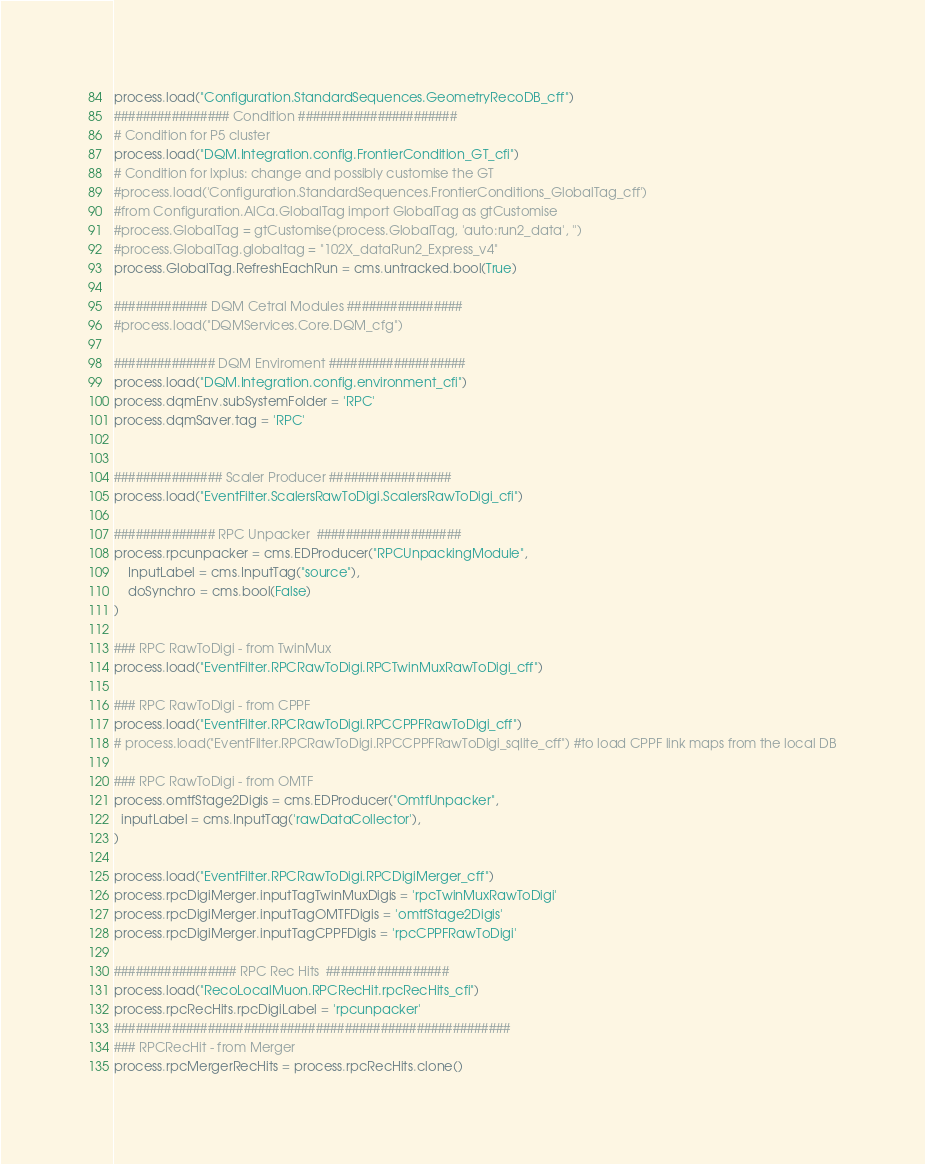<code> <loc_0><loc_0><loc_500><loc_500><_Python_>process.load("Configuration.StandardSequences.GeometryRecoDB_cff")
################ Condition ######################
# Condition for P5 cluster
process.load("DQM.Integration.config.FrontierCondition_GT_cfi")
# Condition for lxplus: change and possibly customise the GT
#process.load('Configuration.StandardSequences.FrontierConditions_GlobalTag_cff')
#from Configuration.AlCa.GlobalTag import GlobalTag as gtCustomise
#process.GlobalTag = gtCustomise(process.GlobalTag, 'auto:run2_data', '')
#process.GlobalTag.globaltag = "102X_dataRun2_Express_v4"
process.GlobalTag.RefreshEachRun = cms.untracked.bool(True)

############# DQM Cetral Modules ################
#process.load("DQMServices.Core.DQM_cfg")

############## DQM Enviroment ###################
process.load("DQM.Integration.config.environment_cfi")
process.dqmEnv.subSystemFolder = 'RPC'
process.dqmSaver.tag = 'RPC'


############### Scaler Producer #################
process.load("EventFilter.ScalersRawToDigi.ScalersRawToDigi_cfi")

############## RPC Unpacker  ####################
process.rpcunpacker = cms.EDProducer("RPCUnpackingModule",
    InputLabel = cms.InputTag("source"),
    doSynchro = cms.bool(False)
)

### RPC RawToDigi - from TwinMux
process.load("EventFilter.RPCRawToDigi.RPCTwinMuxRawToDigi_cff")

### RPC RawToDigi - from CPPF
process.load("EventFilter.RPCRawToDigi.RPCCPPFRawToDigi_cff")
# process.load("EventFilter.RPCRawToDigi.RPCCPPFRawToDigi_sqlite_cff") #to load CPPF link maps from the local DB

### RPC RawToDigi - from OMTF
process.omtfStage2Digis = cms.EDProducer("OmtfUnpacker",
  inputLabel = cms.InputTag('rawDataCollector'),
)

process.load("EventFilter.RPCRawToDigi.RPCDigiMerger_cff")
process.rpcDigiMerger.inputTagTwinMuxDigis = 'rpcTwinMuxRawToDigi'
process.rpcDigiMerger.inputTagOMTFDigis = 'omtfStage2Digis'
process.rpcDigiMerger.inputTagCPPFDigis = 'rpcCPPFRawToDigi'

################# RPC Rec Hits  #################
process.load("RecoLocalMuon.RPCRecHit.rpcRecHits_cfi")
process.rpcRecHits.rpcDigiLabel = 'rpcunpacker'
#######################################################
### RPCRecHit - from Merger
process.rpcMergerRecHits = process.rpcRecHits.clone()</code> 